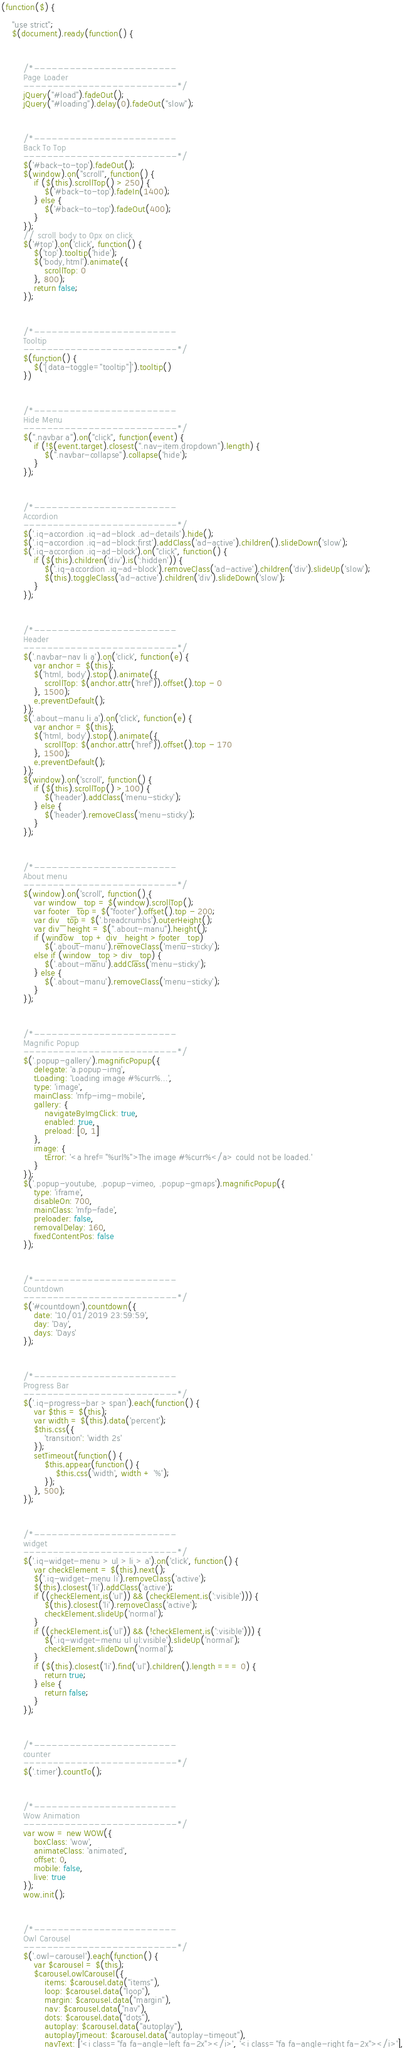<code> <loc_0><loc_0><loc_500><loc_500><_JavaScript_>

(function($) {

	"use strict";
	$(document).ready(function() {



		/*------------------------
		Page Loader
		--------------------------*/
		jQuery("#load").fadeOut();
		jQuery("#loading").delay(0).fadeOut("slow");



		/*------------------------
		Back To Top
		--------------------------*/
		$('#back-to-top').fadeOut();
		$(window).on("scroll", function() {
			if ($(this).scrollTop() > 250) {
				$('#back-to-top').fadeIn(1400);
			} else {
				$('#back-to-top').fadeOut(400);
			}
		});
		// scroll body to 0px on click
		$('#top').on('click', function() {
			$('top').tooltip('hide');
			$('body,html').animate({
				scrollTop: 0
			}, 800);
			return false;
		});



		/*------------------------
		Tooltip
		--------------------------*/
		$(function() {
			$('[data-toggle="tooltip"]').tooltip()
		})



		/*------------------------
		Hide Menu
		--------------------------*/
		$(".navbar a").on("click", function(event) {
			if (!$(event.target).closest(".nav-item.dropdown").length) {
				$(".navbar-collapse").collapse('hide');
			}
		});



		/*------------------------
		Accordion
		--------------------------*/
		$('.iq-accordion .iq-ad-block .ad-details').hide();
		$('.iq-accordion .iq-ad-block:first').addClass('ad-active').children().slideDown('slow');
		$('.iq-accordion .iq-ad-block').on("click", function() {
			if ($(this).children('div').is(':hidden')) {
				$('.iq-accordion .iq-ad-block').removeClass('ad-active').children('div').slideUp('slow');
				$(this).toggleClass('ad-active').children('div').slideDown('slow');
			}
		});



		/*------------------------
		Header
		--------------------------*/
		$('.navbar-nav li a').on('click', function(e) {
			var anchor = $(this);
			$('html, body').stop().animate({
				scrollTop: $(anchor.attr('href')).offset().top - 0
			}, 1500);
			e.preventDefault();
		});
		$('.about-manu li a').on('click', function(e) {
			var anchor = $(this);
			$('html, body').stop().animate({
				scrollTop: $(anchor.attr('href')).offset().top - 170
			}, 1500);
			e.preventDefault();
		});
		$(window).on('scroll', function() {
			if ($(this).scrollTop() > 100) {
				$('header').addClass('menu-sticky');
			} else {
				$('header').removeClass('menu-sticky');
			}
		});



		/*------------------------
		About menu
		--------------------------*/
		$(window).on('scroll', function() {
			var window_top = $(window).scrollTop();
			var footer_top = $("footer").offset().top - 200;
			var div_top = $('.breadcrumbs').outerHeight();
			var div_height = $(".about-manu").height();
			if (window_top + div_height > footer_top)
				$('.about-manu').removeClass('menu-sticky');
			else if (window_top > div_top) {
				$('.about-manu').addClass('menu-sticky');
			} else {
				$('.about-manu').removeClass('menu-sticky');
			}
		});



		/*------------------------
		Magnific Popup
		--------------------------*/
		$('.popup-gallery').magnificPopup({
			delegate: 'a.popup-img',
			tLoading: 'Loading image #%curr%...',
			type: 'image',
			mainClass: 'mfp-img-mobile',
			gallery: {
				navigateByImgClick: true,
				enabled: true,
				preload: [0, 1]
			},
			image: {
				tError: '<a href="%url%">The image #%curr%</a> could not be loaded.'
			}
		});
		$('.popup-youtube, .popup-vimeo, .popup-gmaps').magnificPopup({
			type: 'iframe',
			disableOn: 700,
			mainClass: 'mfp-fade',
			preloader: false,
			removalDelay: 160,
			fixedContentPos: false
		});



		/*------------------------
		Countdown
		--------------------------*/
		$('#countdown').countdown({
			date: '10/01/2019 23:59:59',
			day: 'Day',
			days: 'Days'
		});



		/*------------------------
		Progress Bar
		--------------------------*/
		$('.iq-progress-bar > span').each(function() {
			var $this = $(this);
			var width = $(this).data('percent');
			$this.css({
				'transition': 'width 2s'
			});
			setTimeout(function() {
				$this.appear(function() {
					$this.css('width', width + '%');
				});
			}, 500);
		});



		/*------------------------
		widget
		--------------------------*/
		$('.iq-widget-menu > ul > li > a').on('click', function() {
			var checkElement = $(this).next();
			$('.iq-widget-menu li').removeClass('active');
			$(this).closest('li').addClass('active');
			if ((checkElement.is('ul')) && (checkElement.is(':visible'))) {
				$(this).closest('li').removeClass('active');
				checkElement.slideUp('normal');
			}
			if ((checkElement.is('ul')) && (!checkElement.is(':visible'))) {
				$('.iq-widget-menu ul ul:visible').slideUp('normal');
				checkElement.slideDown('normal');
			}
			if ($(this).closest('li').find('ul').children().length === 0) {
				return true;
			} else {
				return false;
			}
		});



		/*------------------------
		counter
		--------------------------*/
		$('.timer').countTo();



		/*------------------------
		Wow Animation
		--------------------------*/
		var wow = new WOW({
			boxClass: 'wow',
			animateClass: 'animated',
			offset: 0,
			mobile: false,
			live: true
		});
		wow.init();



		/*------------------------
		Owl Carousel
		--------------------------*/
		$('.owl-carousel').each(function() {
			var $carousel = $(this);
			$carousel.owlCarousel({
				items: $carousel.data("items"),
				loop: $carousel.data("loop"),
				margin: $carousel.data("margin"),
				nav: $carousel.data("nav"),
				dots: $carousel.data("dots"),
				autoplay: $carousel.data("autoplay"),
				autoplayTimeout: $carousel.data("autoplay-timeout"),
				navText: ['<i class="fa fa-angle-left fa-2x"></i>', '<i class="fa fa-angle-right fa-2x"></i>'],</code> 